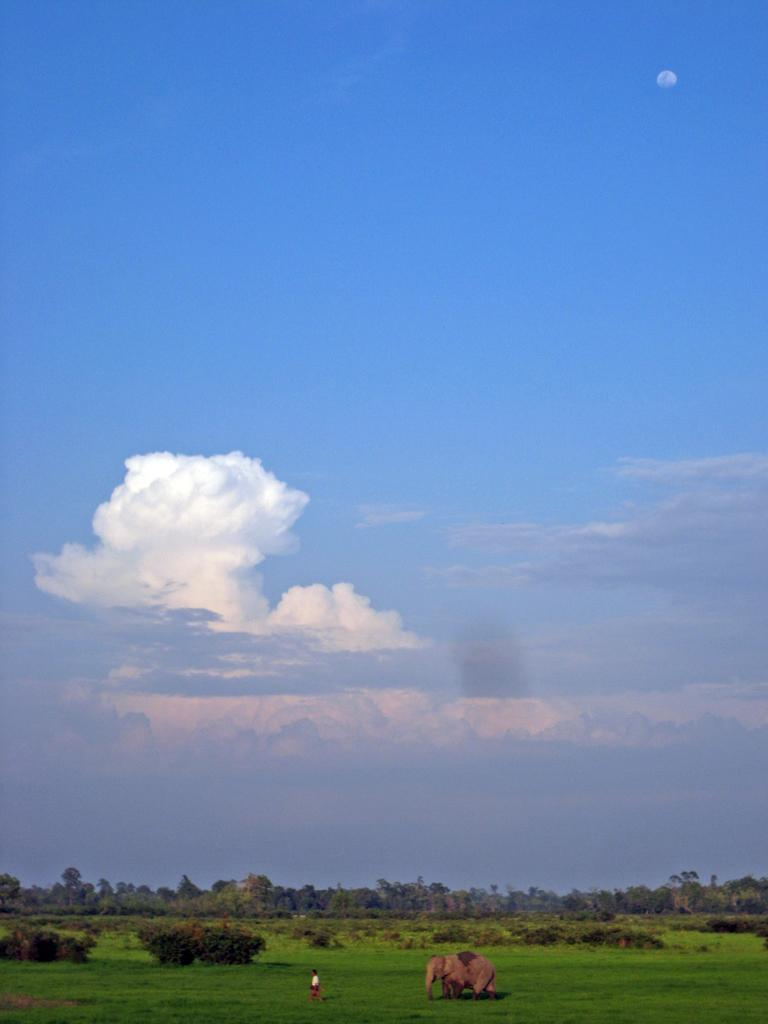What animal can be seen in the image? There is an elephant in the image. What else is present in the image besides the elephant? There is a person on the ground in the image. What can be seen in the background of the image? There are trees and the sky visible in the background of the image. What is the condition of the sky in the image? Clouds are present in the sky. What type of yoke is the elephant using to pull the cart in the image? There is no cart or yoke present in the image; it only features an elephant and a person on the ground. How much oil is being used by the person in the image? There is no indication of oil usage in the image; it only shows an elephant and a person on the ground. 